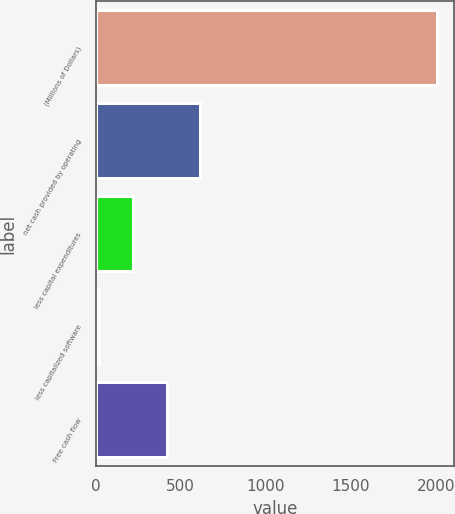<chart> <loc_0><loc_0><loc_500><loc_500><bar_chart><fcel>(Millions of Dollars)<fcel>net cash provided by operating<fcel>less capital expenditures<fcel>less capitalized software<fcel>Free cash flow<nl><fcel>2006<fcel>615.8<fcel>218.6<fcel>20<fcel>417.2<nl></chart> 